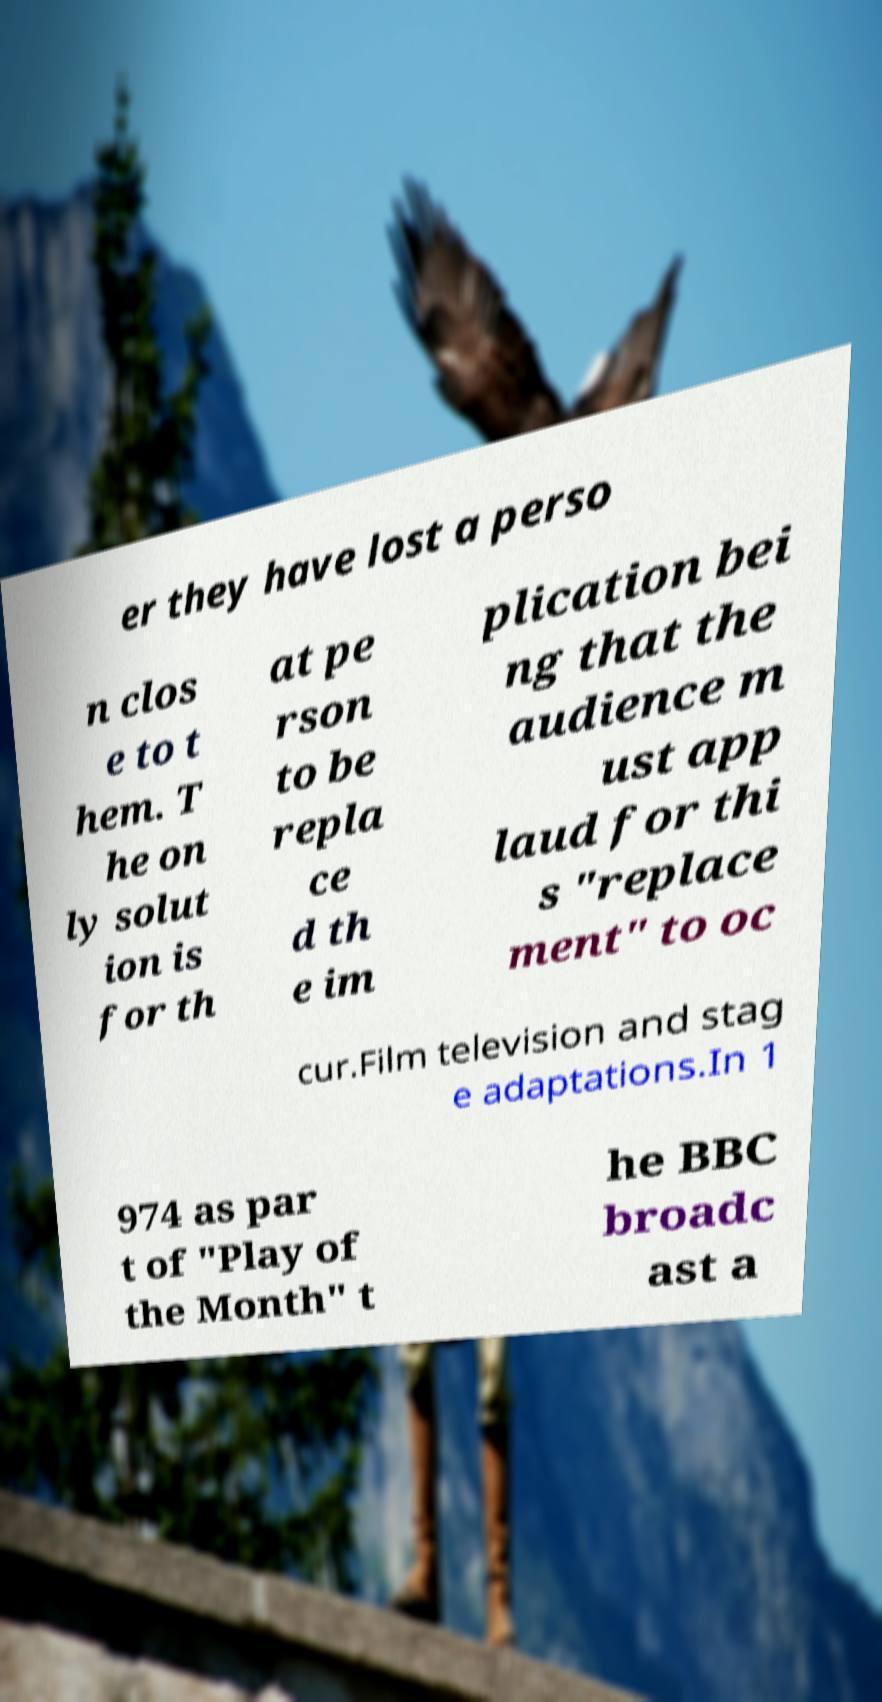There's text embedded in this image that I need extracted. Can you transcribe it verbatim? er they have lost a perso n clos e to t hem. T he on ly solut ion is for th at pe rson to be repla ce d th e im plication bei ng that the audience m ust app laud for thi s "replace ment" to oc cur.Film television and stag e adaptations.In 1 974 as par t of "Play of the Month" t he BBC broadc ast a 